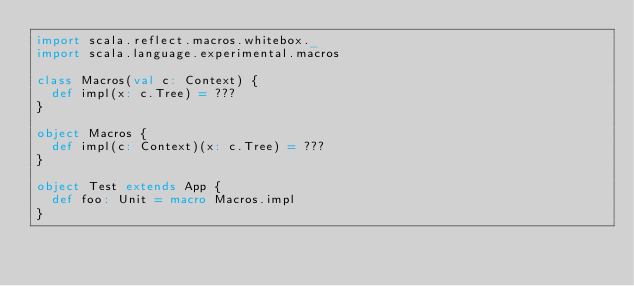Convert code to text. <code><loc_0><loc_0><loc_500><loc_500><_Scala_>import scala.reflect.macros.whitebox._
import scala.language.experimental.macros

class Macros(val c: Context) {
  def impl(x: c.Tree) = ???
}

object Macros {
  def impl(c: Context)(x: c.Tree) = ???
}

object Test extends App {
  def foo: Unit = macro Macros.impl
}
</code> 